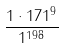<formula> <loc_0><loc_0><loc_500><loc_500>\frac { 1 \cdot 1 7 1 ^ { 9 } } { 1 ^ { 1 9 8 } }</formula> 